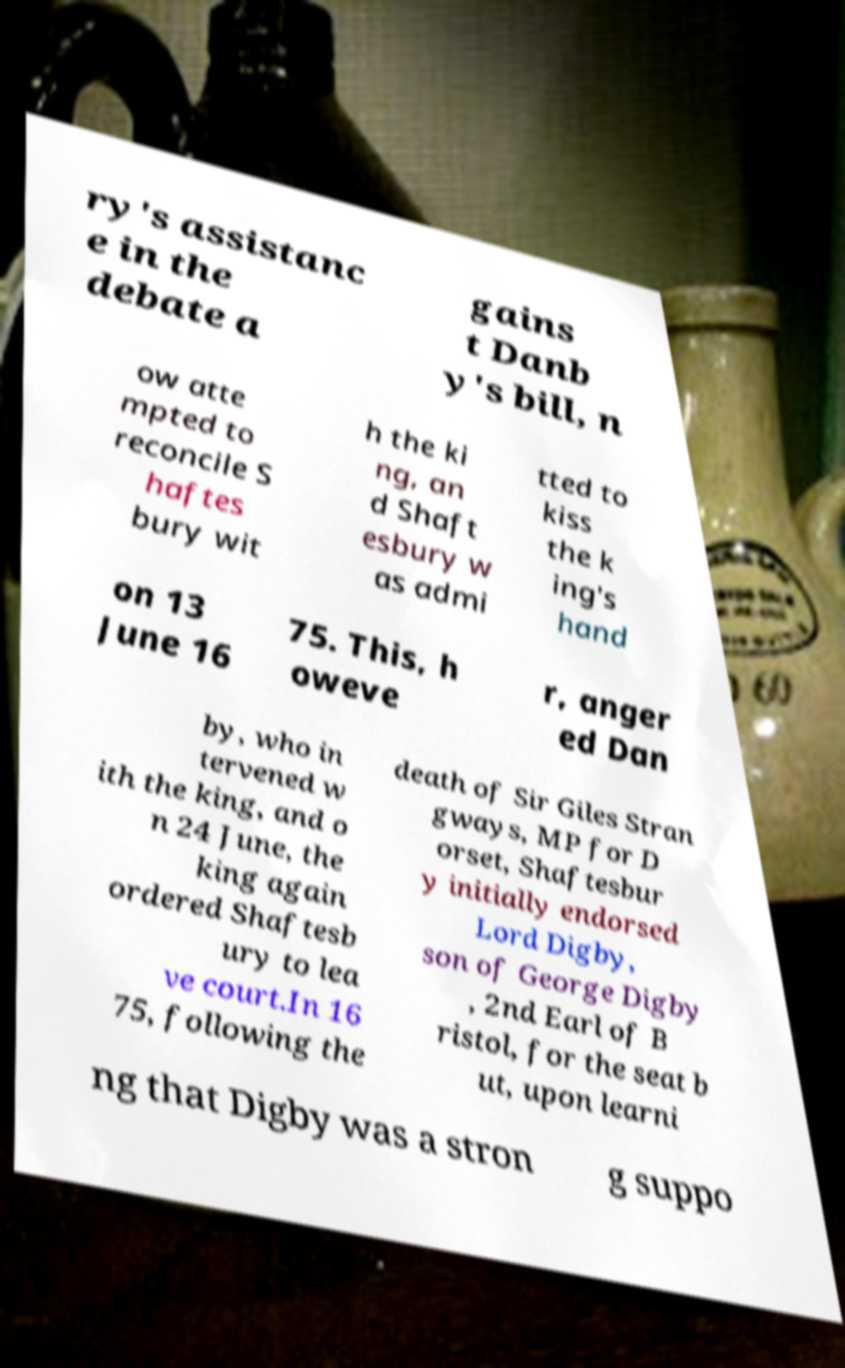Please identify and transcribe the text found in this image. ry's assistanc e in the debate a gains t Danb y's bill, n ow atte mpted to reconcile S haftes bury wit h the ki ng, an d Shaft esbury w as admi tted to kiss the k ing's hand on 13 June 16 75. This, h oweve r, anger ed Dan by, who in tervened w ith the king, and o n 24 June, the king again ordered Shaftesb ury to lea ve court.In 16 75, following the death of Sir Giles Stran gways, MP for D orset, Shaftesbur y initially endorsed Lord Digby, son of George Digby , 2nd Earl of B ristol, for the seat b ut, upon learni ng that Digby was a stron g suppo 